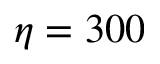<formula> <loc_0><loc_0><loc_500><loc_500>\eta = 3 0 0</formula> 